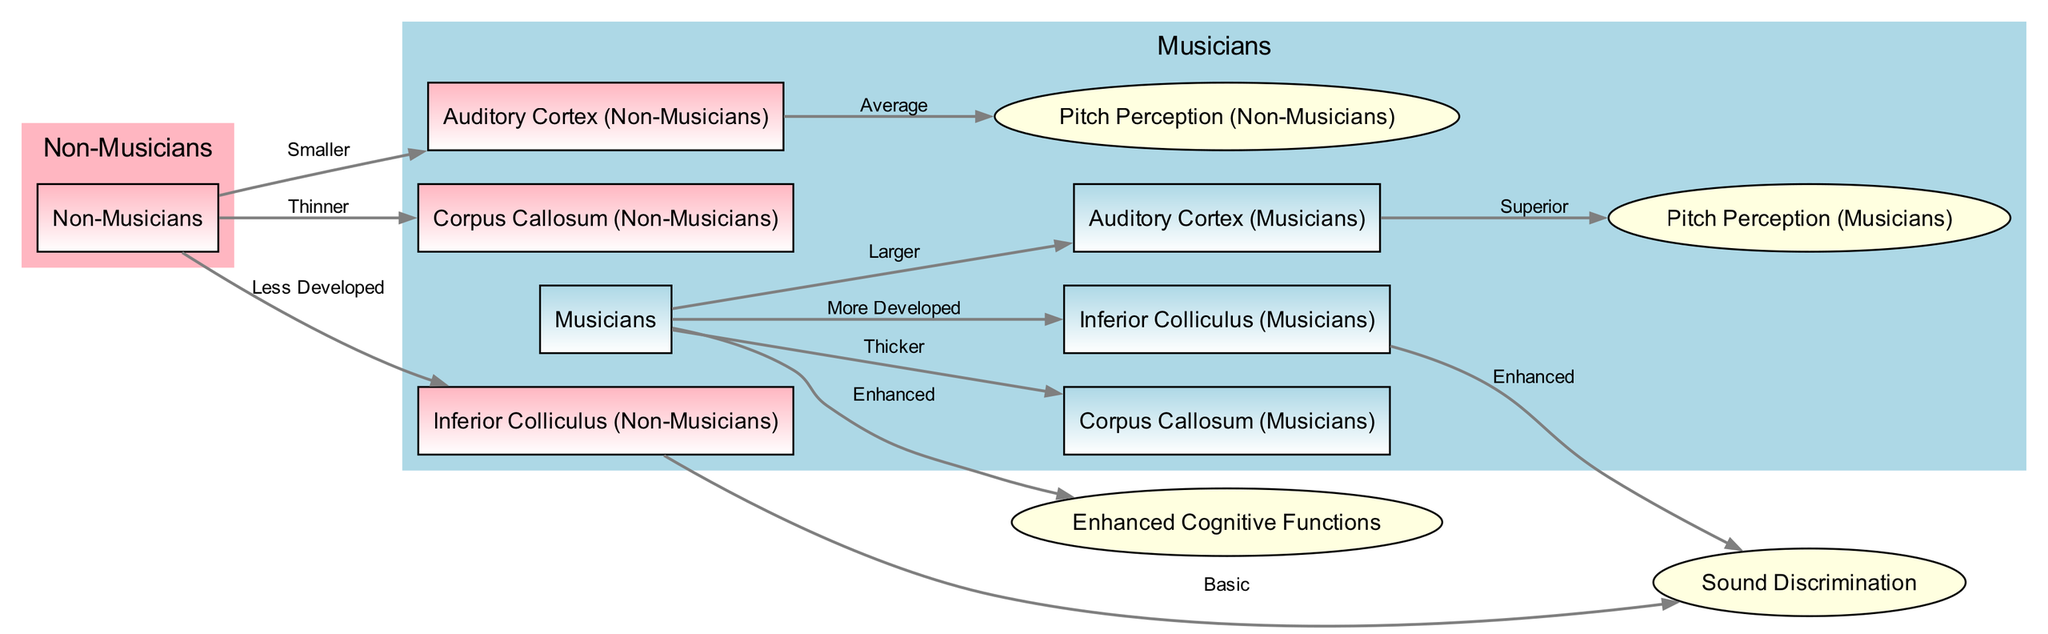What is the relative size of the Auditory Cortex in musicians? The diagram indicates that the Auditory Cortex in musicians is labeled as "Larger" compared to non-musicians, as per the edge connecting "musicians" to "auditory_cortex_musicians."
Answer: Larger What is the thickness of the Corpus Callosum in non-musicians? According to the diagram, the Corpus Callosum in non-musicians is associated with the label "Thinner," derived from the edge connecting "non_musicians" to "corpus_callosum_non_musicians."
Answer: Thinner How are sound discrimination abilities categorized for musicians? The diagram shows that the edge from "inferior_colliculus_musicians" to "sound_discrimination" is labeled as "Enhanced," indicating superior performance in sound discrimination for musicians.
Answer: Enhanced What cognitive advancements are attributed to musicians according to the diagram? The connection from "musicians" to "cognitive_functions" is labeled "Enhanced," suggesting that musicians experience improvements in cognitive functions compared to non-musicians.
Answer: Enhanced What is the pitch perception level in non-musicians? The edge linking "auditory_cortex_non_musicians" to "pitch_perception_non_musicians" is labeled "Average," indicating that non-musicians have an average level of pitch perception.
Answer: Average Which brain structure is described as "More Developed" in musicians? The edge from "musicians" to "inferior_colliculus_musicians" indicates that this structure is "More Developed" in musicians specifically.
Answer: More Developed Which category of individuals shows a basic level of sound discrimination? The label "Basic" is associated with the edge from "inferior_colliculus_non_musicians" to "sound_discrimination," indicating that this is true for non-musicians.
Answer: Non-Musicians What is the relationship between the auditory cortex size and musicians? The diagram shows that the Auditory Cortex in musicians is described as "Larger," which establishes a clear connection regarding size comparison to non-musicians’ auditory cortex.
Answer: Larger How does the inferior colliculus development differ between musicians and non-musicians? The diagram highlights that musicians have a "More Developed" inferior colliculus, while non-musicians have a "Less Developed" version, demonstrating a clear contrast in development between the groups.
Answer: More Developed vs. Less Developed 